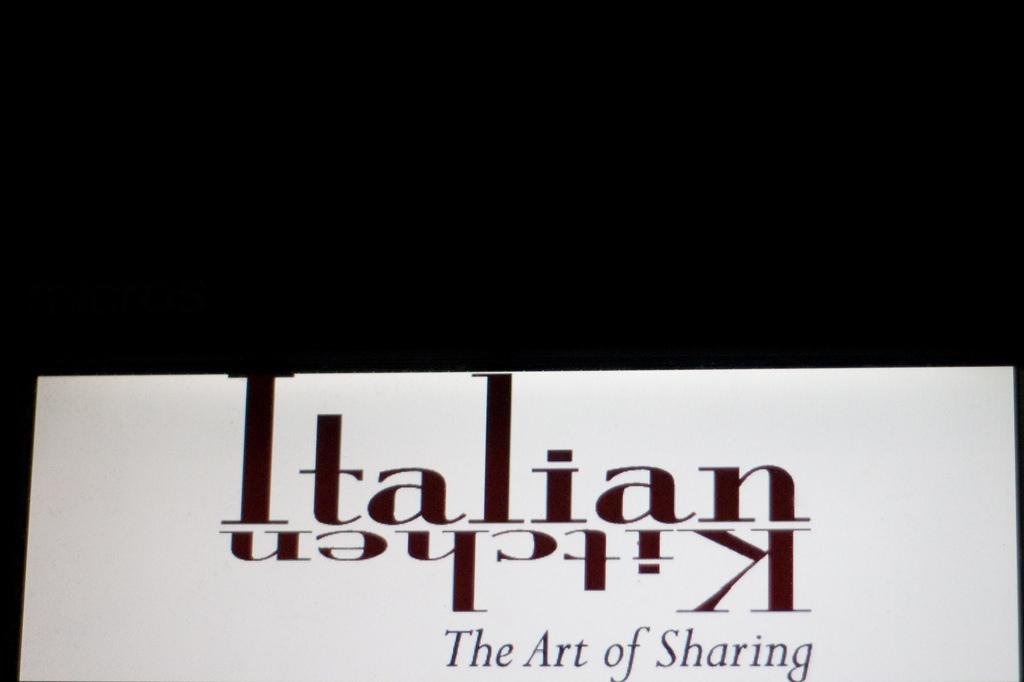<image>
Create a compact narrative representing the image presented. Italian kitchen the art of sharing book by itself 